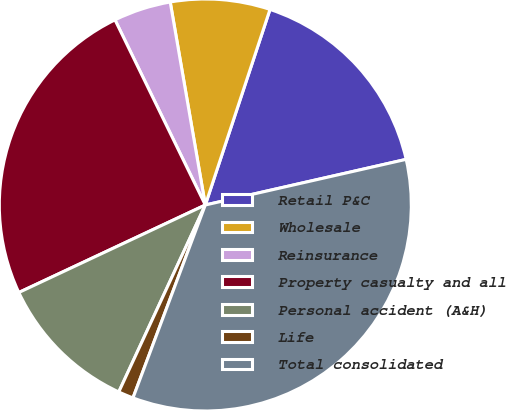<chart> <loc_0><loc_0><loc_500><loc_500><pie_chart><fcel>Retail P&C<fcel>Wholesale<fcel>Reinsurance<fcel>Property casualty and all<fcel>Personal accident (A&H)<fcel>Life<fcel>Total consolidated<nl><fcel>16.36%<fcel>7.81%<fcel>4.5%<fcel>24.76%<fcel>11.12%<fcel>1.19%<fcel>34.27%<nl></chart> 